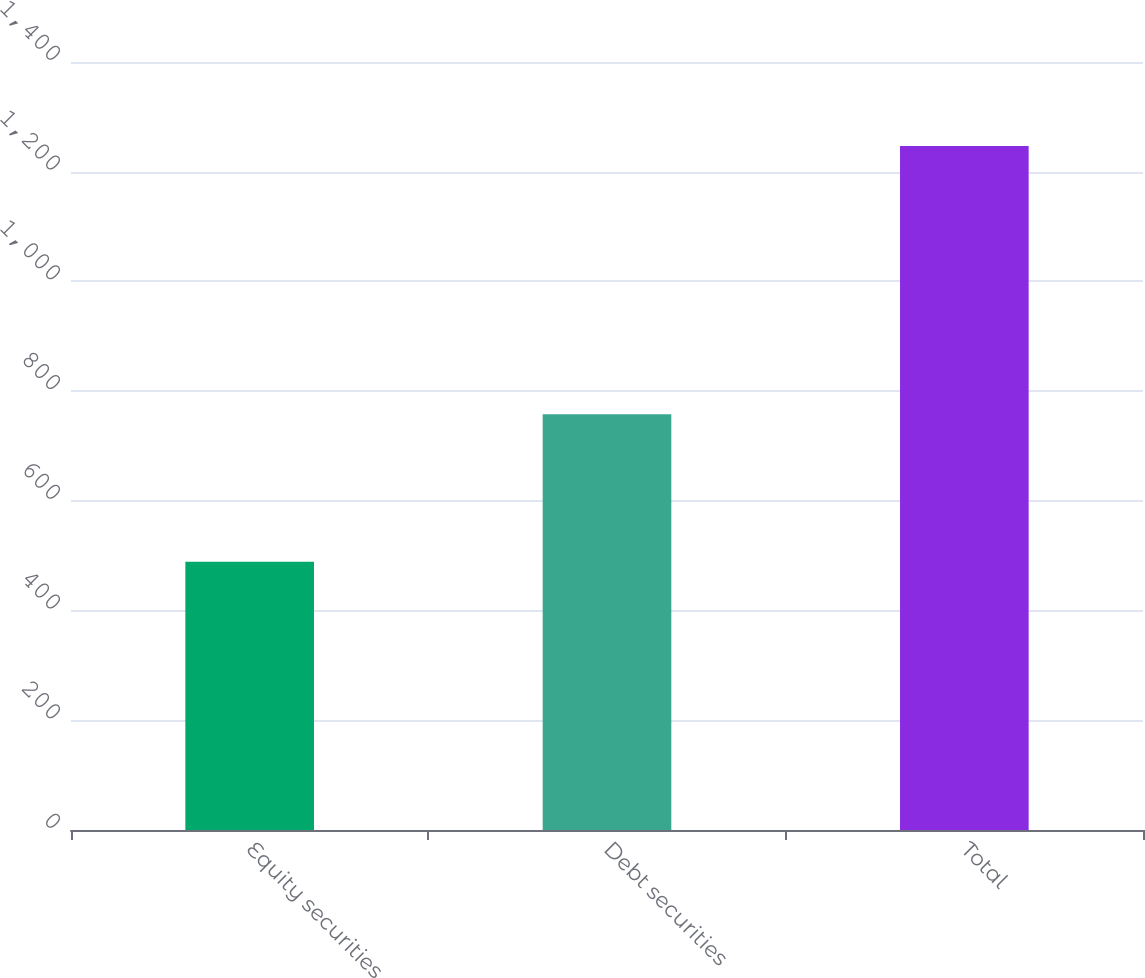Convert chart. <chart><loc_0><loc_0><loc_500><loc_500><bar_chart><fcel>Equity securities<fcel>Debt securities<fcel>Total<nl><fcel>489<fcel>758<fcel>1247<nl></chart> 